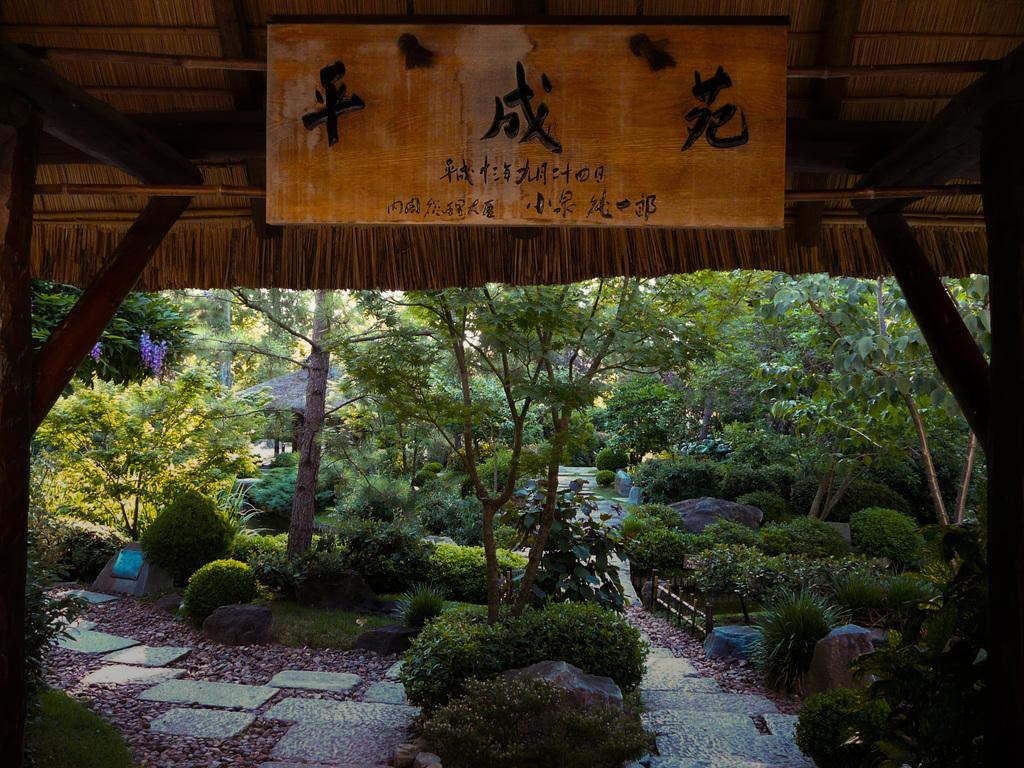Describe this image in one or two sentences. In this image I can see there is a shed and a wooden board with symbols. And there are trees, plants, flowers and stairs. And there is a fence and a stone. 